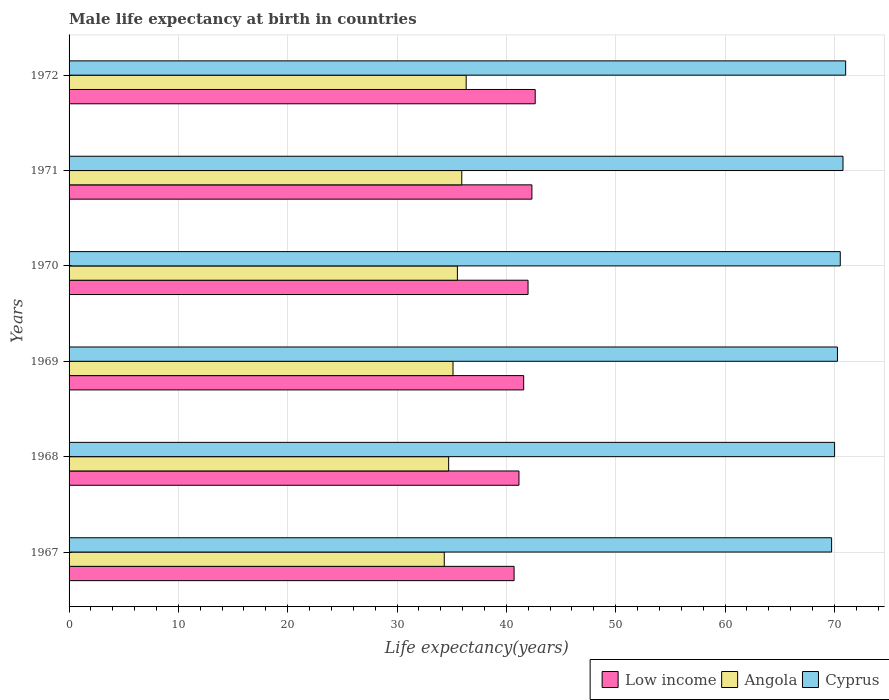How many different coloured bars are there?
Your response must be concise. 3. Are the number of bars per tick equal to the number of legend labels?
Your answer should be very brief. Yes. Are the number of bars on each tick of the Y-axis equal?
Keep it short and to the point. Yes. How many bars are there on the 4th tick from the top?
Your response must be concise. 3. What is the label of the 6th group of bars from the top?
Your response must be concise. 1967. In how many cases, is the number of bars for a given year not equal to the number of legend labels?
Give a very brief answer. 0. What is the male life expectancy at birth in Angola in 1968?
Ensure brevity in your answer.  34.72. Across all years, what is the maximum male life expectancy at birth in Cyprus?
Give a very brief answer. 71.04. Across all years, what is the minimum male life expectancy at birth in Cyprus?
Ensure brevity in your answer.  69.75. In which year was the male life expectancy at birth in Low income maximum?
Offer a terse response. 1972. In which year was the male life expectancy at birth in Cyprus minimum?
Your response must be concise. 1967. What is the total male life expectancy at birth in Angola in the graph?
Provide a short and direct response. 211.93. What is the difference between the male life expectancy at birth in Low income in 1971 and that in 1972?
Provide a short and direct response. -0.3. What is the difference between the male life expectancy at birth in Angola in 1967 and the male life expectancy at birth in Low income in 1972?
Keep it short and to the point. -8.32. What is the average male life expectancy at birth in Low income per year?
Offer a terse response. 41.73. In the year 1972, what is the difference between the male life expectancy at birth in Cyprus and male life expectancy at birth in Low income?
Provide a succinct answer. 28.4. What is the ratio of the male life expectancy at birth in Cyprus in 1967 to that in 1970?
Your response must be concise. 0.99. Is the male life expectancy at birth in Low income in 1967 less than that in 1969?
Provide a short and direct response. Yes. Is the difference between the male life expectancy at birth in Cyprus in 1969 and 1970 greater than the difference between the male life expectancy at birth in Low income in 1969 and 1970?
Your response must be concise. Yes. What is the difference between the highest and the second highest male life expectancy at birth in Low income?
Your response must be concise. 0.3. What is the difference between the highest and the lowest male life expectancy at birth in Cyprus?
Your answer should be compact. 1.28. Is the sum of the male life expectancy at birth in Low income in 1971 and 1972 greater than the maximum male life expectancy at birth in Angola across all years?
Keep it short and to the point. Yes. What does the 2nd bar from the top in 1967 represents?
Your response must be concise. Angola. What does the 3rd bar from the bottom in 1969 represents?
Provide a succinct answer. Cyprus. Is it the case that in every year, the sum of the male life expectancy at birth in Angola and male life expectancy at birth in Low income is greater than the male life expectancy at birth in Cyprus?
Your answer should be compact. Yes. How many bars are there?
Your answer should be compact. 18. Are all the bars in the graph horizontal?
Offer a terse response. Yes. How many years are there in the graph?
Make the answer very short. 6. Are the values on the major ticks of X-axis written in scientific E-notation?
Ensure brevity in your answer.  No. Does the graph contain any zero values?
Make the answer very short. No. Where does the legend appear in the graph?
Offer a terse response. Bottom right. How are the legend labels stacked?
Keep it short and to the point. Horizontal. What is the title of the graph?
Keep it short and to the point. Male life expectancy at birth in countries. What is the label or title of the X-axis?
Ensure brevity in your answer.  Life expectancy(years). What is the label or title of the Y-axis?
Your response must be concise. Years. What is the Life expectancy(years) in Low income in 1967?
Provide a short and direct response. 40.71. What is the Life expectancy(years) in Angola in 1967?
Offer a very short reply. 34.32. What is the Life expectancy(years) of Cyprus in 1967?
Make the answer very short. 69.75. What is the Life expectancy(years) of Low income in 1968?
Provide a short and direct response. 41.15. What is the Life expectancy(years) of Angola in 1968?
Provide a short and direct response. 34.72. What is the Life expectancy(years) of Cyprus in 1968?
Your answer should be very brief. 70.02. What is the Life expectancy(years) of Low income in 1969?
Keep it short and to the point. 41.58. What is the Life expectancy(years) of Angola in 1969?
Your response must be concise. 35.12. What is the Life expectancy(years) of Cyprus in 1969?
Your answer should be compact. 70.28. What is the Life expectancy(years) of Low income in 1970?
Offer a very short reply. 41.98. What is the Life expectancy(years) of Angola in 1970?
Offer a very short reply. 35.52. What is the Life expectancy(years) in Cyprus in 1970?
Provide a succinct answer. 70.54. What is the Life expectancy(years) of Low income in 1971?
Ensure brevity in your answer.  42.34. What is the Life expectancy(years) in Angola in 1971?
Your answer should be very brief. 35.92. What is the Life expectancy(years) of Cyprus in 1971?
Your answer should be very brief. 70.79. What is the Life expectancy(years) of Low income in 1972?
Give a very brief answer. 42.64. What is the Life expectancy(years) in Angola in 1972?
Ensure brevity in your answer.  36.32. What is the Life expectancy(years) in Cyprus in 1972?
Offer a very short reply. 71.04. Across all years, what is the maximum Life expectancy(years) in Low income?
Keep it short and to the point. 42.64. Across all years, what is the maximum Life expectancy(years) of Angola?
Make the answer very short. 36.32. Across all years, what is the maximum Life expectancy(years) in Cyprus?
Your answer should be very brief. 71.04. Across all years, what is the minimum Life expectancy(years) of Low income?
Offer a terse response. 40.71. Across all years, what is the minimum Life expectancy(years) of Angola?
Keep it short and to the point. 34.32. Across all years, what is the minimum Life expectancy(years) of Cyprus?
Provide a short and direct response. 69.75. What is the total Life expectancy(years) in Low income in the graph?
Ensure brevity in your answer.  250.4. What is the total Life expectancy(years) of Angola in the graph?
Provide a short and direct response. 211.93. What is the total Life expectancy(years) in Cyprus in the graph?
Give a very brief answer. 422.43. What is the difference between the Life expectancy(years) of Low income in 1967 and that in 1968?
Offer a terse response. -0.45. What is the difference between the Life expectancy(years) in Angola in 1967 and that in 1968?
Make the answer very short. -0.4. What is the difference between the Life expectancy(years) of Cyprus in 1967 and that in 1968?
Ensure brevity in your answer.  -0.27. What is the difference between the Life expectancy(years) of Low income in 1967 and that in 1969?
Your response must be concise. -0.88. What is the difference between the Life expectancy(years) in Angola in 1967 and that in 1969?
Provide a short and direct response. -0.8. What is the difference between the Life expectancy(years) in Cyprus in 1967 and that in 1969?
Your response must be concise. -0.53. What is the difference between the Life expectancy(years) in Low income in 1967 and that in 1970?
Make the answer very short. -1.28. What is the difference between the Life expectancy(years) of Angola in 1967 and that in 1970?
Your answer should be very brief. -1.2. What is the difference between the Life expectancy(years) of Cyprus in 1967 and that in 1970?
Your answer should be compact. -0.79. What is the difference between the Life expectancy(years) of Low income in 1967 and that in 1971?
Keep it short and to the point. -1.63. What is the difference between the Life expectancy(years) of Angola in 1967 and that in 1971?
Your answer should be compact. -1.6. What is the difference between the Life expectancy(years) in Cyprus in 1967 and that in 1971?
Offer a terse response. -1.04. What is the difference between the Life expectancy(years) of Low income in 1967 and that in 1972?
Keep it short and to the point. -1.93. What is the difference between the Life expectancy(years) of Angola in 1967 and that in 1972?
Your answer should be very brief. -2. What is the difference between the Life expectancy(years) in Cyprus in 1967 and that in 1972?
Your answer should be very brief. -1.28. What is the difference between the Life expectancy(years) in Low income in 1968 and that in 1969?
Give a very brief answer. -0.43. What is the difference between the Life expectancy(years) of Angola in 1968 and that in 1969?
Your response must be concise. -0.4. What is the difference between the Life expectancy(years) in Cyprus in 1968 and that in 1969?
Provide a succinct answer. -0.26. What is the difference between the Life expectancy(years) of Low income in 1968 and that in 1970?
Keep it short and to the point. -0.83. What is the difference between the Life expectancy(years) of Angola in 1968 and that in 1970?
Offer a terse response. -0.8. What is the difference between the Life expectancy(years) in Cyprus in 1968 and that in 1970?
Offer a very short reply. -0.52. What is the difference between the Life expectancy(years) of Low income in 1968 and that in 1971?
Your answer should be very brief. -1.18. What is the difference between the Life expectancy(years) of Angola in 1968 and that in 1971?
Your answer should be very brief. -1.2. What is the difference between the Life expectancy(years) in Cyprus in 1968 and that in 1971?
Your response must be concise. -0.77. What is the difference between the Life expectancy(years) in Low income in 1968 and that in 1972?
Your answer should be very brief. -1.49. What is the difference between the Life expectancy(years) of Angola in 1968 and that in 1972?
Keep it short and to the point. -1.6. What is the difference between the Life expectancy(years) in Cyprus in 1968 and that in 1972?
Ensure brevity in your answer.  -1.01. What is the difference between the Life expectancy(years) in Low income in 1969 and that in 1970?
Your answer should be compact. -0.4. What is the difference between the Life expectancy(years) in Angola in 1969 and that in 1970?
Offer a terse response. -0.4. What is the difference between the Life expectancy(years) of Cyprus in 1969 and that in 1970?
Offer a terse response. -0.26. What is the difference between the Life expectancy(years) in Low income in 1969 and that in 1971?
Offer a very short reply. -0.75. What is the difference between the Life expectancy(years) in Angola in 1969 and that in 1971?
Ensure brevity in your answer.  -0.8. What is the difference between the Life expectancy(years) in Cyprus in 1969 and that in 1971?
Offer a terse response. -0.51. What is the difference between the Life expectancy(years) of Low income in 1969 and that in 1972?
Keep it short and to the point. -1.05. What is the difference between the Life expectancy(years) in Angola in 1969 and that in 1972?
Make the answer very short. -1.2. What is the difference between the Life expectancy(years) in Cyprus in 1969 and that in 1972?
Your answer should be very brief. -0.75. What is the difference between the Life expectancy(years) of Low income in 1970 and that in 1971?
Offer a terse response. -0.35. What is the difference between the Life expectancy(years) in Angola in 1970 and that in 1971?
Give a very brief answer. -0.4. What is the difference between the Life expectancy(years) of Low income in 1970 and that in 1972?
Offer a terse response. -0.66. What is the difference between the Life expectancy(years) in Angola in 1970 and that in 1972?
Your response must be concise. -0.8. What is the difference between the Life expectancy(years) of Cyprus in 1970 and that in 1972?
Offer a terse response. -0.49. What is the difference between the Life expectancy(years) in Low income in 1971 and that in 1972?
Offer a terse response. -0.3. What is the difference between the Life expectancy(years) of Angola in 1971 and that in 1972?
Give a very brief answer. -0.4. What is the difference between the Life expectancy(years) of Cyprus in 1971 and that in 1972?
Ensure brevity in your answer.  -0.24. What is the difference between the Life expectancy(years) of Low income in 1967 and the Life expectancy(years) of Angola in 1968?
Give a very brief answer. 5.99. What is the difference between the Life expectancy(years) of Low income in 1967 and the Life expectancy(years) of Cyprus in 1968?
Ensure brevity in your answer.  -29.31. What is the difference between the Life expectancy(years) of Angola in 1967 and the Life expectancy(years) of Cyprus in 1968?
Provide a short and direct response. -35.7. What is the difference between the Life expectancy(years) of Low income in 1967 and the Life expectancy(years) of Angola in 1969?
Your response must be concise. 5.59. What is the difference between the Life expectancy(years) in Low income in 1967 and the Life expectancy(years) in Cyprus in 1969?
Make the answer very short. -29.58. What is the difference between the Life expectancy(years) in Angola in 1967 and the Life expectancy(years) in Cyprus in 1969?
Ensure brevity in your answer.  -35.97. What is the difference between the Life expectancy(years) of Low income in 1967 and the Life expectancy(years) of Angola in 1970?
Provide a short and direct response. 5.19. What is the difference between the Life expectancy(years) in Low income in 1967 and the Life expectancy(years) in Cyprus in 1970?
Provide a short and direct response. -29.83. What is the difference between the Life expectancy(years) in Angola in 1967 and the Life expectancy(years) in Cyprus in 1970?
Offer a very short reply. -36.22. What is the difference between the Life expectancy(years) in Low income in 1967 and the Life expectancy(years) in Angola in 1971?
Your answer should be compact. 4.79. What is the difference between the Life expectancy(years) in Low income in 1967 and the Life expectancy(years) in Cyprus in 1971?
Make the answer very short. -30.08. What is the difference between the Life expectancy(years) of Angola in 1967 and the Life expectancy(years) of Cyprus in 1971?
Keep it short and to the point. -36.47. What is the difference between the Life expectancy(years) of Low income in 1967 and the Life expectancy(years) of Angola in 1972?
Provide a short and direct response. 4.38. What is the difference between the Life expectancy(years) of Low income in 1967 and the Life expectancy(years) of Cyprus in 1972?
Keep it short and to the point. -30.33. What is the difference between the Life expectancy(years) in Angola in 1967 and the Life expectancy(years) in Cyprus in 1972?
Give a very brief answer. -36.72. What is the difference between the Life expectancy(years) of Low income in 1968 and the Life expectancy(years) of Angola in 1969?
Your answer should be compact. 6.03. What is the difference between the Life expectancy(years) in Low income in 1968 and the Life expectancy(years) in Cyprus in 1969?
Make the answer very short. -29.13. What is the difference between the Life expectancy(years) in Angola in 1968 and the Life expectancy(years) in Cyprus in 1969?
Offer a terse response. -35.56. What is the difference between the Life expectancy(years) in Low income in 1968 and the Life expectancy(years) in Angola in 1970?
Your response must be concise. 5.63. What is the difference between the Life expectancy(years) of Low income in 1968 and the Life expectancy(years) of Cyprus in 1970?
Provide a succinct answer. -29.39. What is the difference between the Life expectancy(years) in Angola in 1968 and the Life expectancy(years) in Cyprus in 1970?
Your response must be concise. -35.82. What is the difference between the Life expectancy(years) of Low income in 1968 and the Life expectancy(years) of Angola in 1971?
Offer a terse response. 5.23. What is the difference between the Life expectancy(years) in Low income in 1968 and the Life expectancy(years) in Cyprus in 1971?
Provide a succinct answer. -29.64. What is the difference between the Life expectancy(years) in Angola in 1968 and the Life expectancy(years) in Cyprus in 1971?
Provide a succinct answer. -36.07. What is the difference between the Life expectancy(years) in Low income in 1968 and the Life expectancy(years) in Angola in 1972?
Ensure brevity in your answer.  4.83. What is the difference between the Life expectancy(years) of Low income in 1968 and the Life expectancy(years) of Cyprus in 1972?
Your answer should be compact. -29.88. What is the difference between the Life expectancy(years) in Angola in 1968 and the Life expectancy(years) in Cyprus in 1972?
Give a very brief answer. -36.32. What is the difference between the Life expectancy(years) of Low income in 1969 and the Life expectancy(years) of Angola in 1970?
Provide a short and direct response. 6.06. What is the difference between the Life expectancy(years) in Low income in 1969 and the Life expectancy(years) in Cyprus in 1970?
Give a very brief answer. -28.96. What is the difference between the Life expectancy(years) in Angola in 1969 and the Life expectancy(years) in Cyprus in 1970?
Give a very brief answer. -35.42. What is the difference between the Life expectancy(years) in Low income in 1969 and the Life expectancy(years) in Angola in 1971?
Offer a terse response. 5.66. What is the difference between the Life expectancy(years) in Low income in 1969 and the Life expectancy(years) in Cyprus in 1971?
Offer a very short reply. -29.21. What is the difference between the Life expectancy(years) of Angola in 1969 and the Life expectancy(years) of Cyprus in 1971?
Offer a terse response. -35.67. What is the difference between the Life expectancy(years) of Low income in 1969 and the Life expectancy(years) of Angola in 1972?
Make the answer very short. 5.26. What is the difference between the Life expectancy(years) in Low income in 1969 and the Life expectancy(years) in Cyprus in 1972?
Keep it short and to the point. -29.45. What is the difference between the Life expectancy(years) of Angola in 1969 and the Life expectancy(years) of Cyprus in 1972?
Your answer should be very brief. -35.92. What is the difference between the Life expectancy(years) of Low income in 1970 and the Life expectancy(years) of Angola in 1971?
Provide a succinct answer. 6.06. What is the difference between the Life expectancy(years) in Low income in 1970 and the Life expectancy(years) in Cyprus in 1971?
Provide a succinct answer. -28.81. What is the difference between the Life expectancy(years) in Angola in 1970 and the Life expectancy(years) in Cyprus in 1971?
Your response must be concise. -35.27. What is the difference between the Life expectancy(years) in Low income in 1970 and the Life expectancy(years) in Angola in 1972?
Offer a terse response. 5.66. What is the difference between the Life expectancy(years) in Low income in 1970 and the Life expectancy(years) in Cyprus in 1972?
Provide a succinct answer. -29.05. What is the difference between the Life expectancy(years) in Angola in 1970 and the Life expectancy(years) in Cyprus in 1972?
Your answer should be very brief. -35.52. What is the difference between the Life expectancy(years) of Low income in 1971 and the Life expectancy(years) of Angola in 1972?
Your answer should be compact. 6.01. What is the difference between the Life expectancy(years) in Low income in 1971 and the Life expectancy(years) in Cyprus in 1972?
Make the answer very short. -28.7. What is the difference between the Life expectancy(years) of Angola in 1971 and the Life expectancy(years) of Cyprus in 1972?
Your response must be concise. -35.11. What is the average Life expectancy(years) of Low income per year?
Your answer should be compact. 41.73. What is the average Life expectancy(years) of Angola per year?
Your answer should be compact. 35.32. What is the average Life expectancy(years) of Cyprus per year?
Make the answer very short. 70.4. In the year 1967, what is the difference between the Life expectancy(years) of Low income and Life expectancy(years) of Angola?
Your response must be concise. 6.39. In the year 1967, what is the difference between the Life expectancy(years) of Low income and Life expectancy(years) of Cyprus?
Your answer should be compact. -29.04. In the year 1967, what is the difference between the Life expectancy(years) of Angola and Life expectancy(years) of Cyprus?
Keep it short and to the point. -35.43. In the year 1968, what is the difference between the Life expectancy(years) in Low income and Life expectancy(years) in Angola?
Provide a succinct answer. 6.43. In the year 1968, what is the difference between the Life expectancy(years) in Low income and Life expectancy(years) in Cyprus?
Make the answer very short. -28.87. In the year 1968, what is the difference between the Life expectancy(years) of Angola and Life expectancy(years) of Cyprus?
Your answer should be very brief. -35.3. In the year 1969, what is the difference between the Life expectancy(years) in Low income and Life expectancy(years) in Angola?
Your response must be concise. 6.46. In the year 1969, what is the difference between the Life expectancy(years) of Low income and Life expectancy(years) of Cyprus?
Keep it short and to the point. -28.7. In the year 1969, what is the difference between the Life expectancy(years) in Angola and Life expectancy(years) in Cyprus?
Your response must be concise. -35.16. In the year 1970, what is the difference between the Life expectancy(years) of Low income and Life expectancy(years) of Angola?
Provide a short and direct response. 6.46. In the year 1970, what is the difference between the Life expectancy(years) of Low income and Life expectancy(years) of Cyprus?
Provide a short and direct response. -28.56. In the year 1970, what is the difference between the Life expectancy(years) in Angola and Life expectancy(years) in Cyprus?
Provide a succinct answer. -35.02. In the year 1971, what is the difference between the Life expectancy(years) in Low income and Life expectancy(years) in Angola?
Your answer should be compact. 6.41. In the year 1971, what is the difference between the Life expectancy(years) in Low income and Life expectancy(years) in Cyprus?
Give a very brief answer. -28.46. In the year 1971, what is the difference between the Life expectancy(years) of Angola and Life expectancy(years) of Cyprus?
Ensure brevity in your answer.  -34.87. In the year 1972, what is the difference between the Life expectancy(years) of Low income and Life expectancy(years) of Angola?
Make the answer very short. 6.31. In the year 1972, what is the difference between the Life expectancy(years) in Low income and Life expectancy(years) in Cyprus?
Your answer should be very brief. -28.4. In the year 1972, what is the difference between the Life expectancy(years) in Angola and Life expectancy(years) in Cyprus?
Give a very brief answer. -34.71. What is the ratio of the Life expectancy(years) in Low income in 1967 to that in 1968?
Offer a terse response. 0.99. What is the ratio of the Life expectancy(years) of Cyprus in 1967 to that in 1968?
Your response must be concise. 1. What is the ratio of the Life expectancy(years) of Low income in 1967 to that in 1969?
Ensure brevity in your answer.  0.98. What is the ratio of the Life expectancy(years) of Angola in 1967 to that in 1969?
Ensure brevity in your answer.  0.98. What is the ratio of the Life expectancy(years) in Cyprus in 1967 to that in 1969?
Provide a succinct answer. 0.99. What is the ratio of the Life expectancy(years) in Low income in 1967 to that in 1970?
Provide a succinct answer. 0.97. What is the ratio of the Life expectancy(years) of Angola in 1967 to that in 1970?
Your response must be concise. 0.97. What is the ratio of the Life expectancy(years) of Low income in 1967 to that in 1971?
Offer a terse response. 0.96. What is the ratio of the Life expectancy(years) in Angola in 1967 to that in 1971?
Offer a terse response. 0.96. What is the ratio of the Life expectancy(years) of Low income in 1967 to that in 1972?
Give a very brief answer. 0.95. What is the ratio of the Life expectancy(years) in Angola in 1967 to that in 1972?
Provide a succinct answer. 0.94. What is the ratio of the Life expectancy(years) of Cyprus in 1967 to that in 1972?
Your answer should be very brief. 0.98. What is the ratio of the Life expectancy(years) in Low income in 1968 to that in 1969?
Provide a succinct answer. 0.99. What is the ratio of the Life expectancy(years) of Angola in 1968 to that in 1969?
Your answer should be compact. 0.99. What is the ratio of the Life expectancy(years) of Cyprus in 1968 to that in 1969?
Keep it short and to the point. 1. What is the ratio of the Life expectancy(years) in Low income in 1968 to that in 1970?
Your answer should be compact. 0.98. What is the ratio of the Life expectancy(years) of Angola in 1968 to that in 1970?
Your response must be concise. 0.98. What is the ratio of the Life expectancy(years) in Cyprus in 1968 to that in 1970?
Make the answer very short. 0.99. What is the ratio of the Life expectancy(years) in Low income in 1968 to that in 1971?
Your response must be concise. 0.97. What is the ratio of the Life expectancy(years) in Angola in 1968 to that in 1971?
Provide a succinct answer. 0.97. What is the ratio of the Life expectancy(years) of Cyprus in 1968 to that in 1971?
Provide a short and direct response. 0.99. What is the ratio of the Life expectancy(years) of Low income in 1968 to that in 1972?
Offer a terse response. 0.97. What is the ratio of the Life expectancy(years) in Angola in 1968 to that in 1972?
Your answer should be very brief. 0.96. What is the ratio of the Life expectancy(years) in Cyprus in 1968 to that in 1972?
Your answer should be compact. 0.99. What is the ratio of the Life expectancy(years) in Low income in 1969 to that in 1970?
Ensure brevity in your answer.  0.99. What is the ratio of the Life expectancy(years) of Angola in 1969 to that in 1970?
Make the answer very short. 0.99. What is the ratio of the Life expectancy(years) in Low income in 1969 to that in 1971?
Your response must be concise. 0.98. What is the ratio of the Life expectancy(years) in Angola in 1969 to that in 1971?
Keep it short and to the point. 0.98. What is the ratio of the Life expectancy(years) in Low income in 1969 to that in 1972?
Make the answer very short. 0.98. What is the ratio of the Life expectancy(years) in Angola in 1969 to that in 1972?
Provide a short and direct response. 0.97. What is the ratio of the Life expectancy(years) in Cyprus in 1969 to that in 1972?
Your response must be concise. 0.99. What is the ratio of the Life expectancy(years) in Angola in 1970 to that in 1971?
Your answer should be very brief. 0.99. What is the ratio of the Life expectancy(years) in Low income in 1970 to that in 1972?
Offer a very short reply. 0.98. What is the ratio of the Life expectancy(years) of Angola in 1970 to that in 1972?
Provide a short and direct response. 0.98. What is the ratio of the Life expectancy(years) of Cyprus in 1970 to that in 1972?
Offer a terse response. 0.99. What is the ratio of the Life expectancy(years) of Angola in 1971 to that in 1972?
Your answer should be compact. 0.99. What is the difference between the highest and the second highest Life expectancy(years) in Low income?
Provide a short and direct response. 0.3. What is the difference between the highest and the second highest Life expectancy(years) in Angola?
Offer a very short reply. 0.4. What is the difference between the highest and the second highest Life expectancy(years) of Cyprus?
Give a very brief answer. 0.24. What is the difference between the highest and the lowest Life expectancy(years) of Low income?
Provide a succinct answer. 1.93. What is the difference between the highest and the lowest Life expectancy(years) in Angola?
Make the answer very short. 2. What is the difference between the highest and the lowest Life expectancy(years) in Cyprus?
Keep it short and to the point. 1.28. 